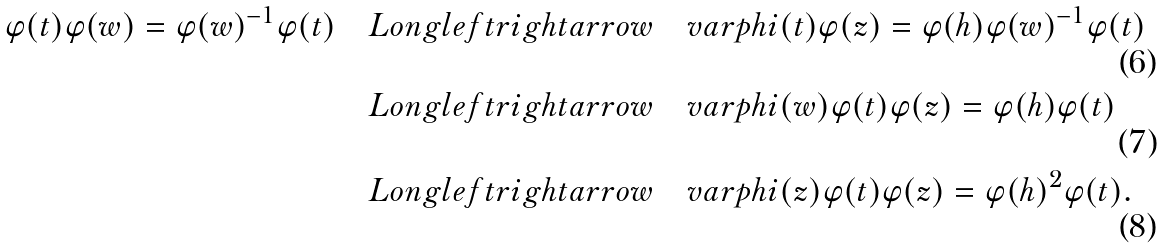<formula> <loc_0><loc_0><loc_500><loc_500>\varphi ( t ) \varphi ( w ) = \varphi ( w ) ^ { - 1 } \varphi ( t ) & \quad L o n g l e f t r i g h t a r r o w \quad v a r p h i ( t ) \varphi ( z ) = \varphi ( h ) \varphi ( w ) ^ { - 1 } \varphi ( t ) \\ & \quad L o n g l e f t r i g h t a r r o w \quad v a r p h i ( w ) \varphi ( t ) \varphi ( z ) = \varphi ( h ) \varphi ( t ) \\ & \quad L o n g l e f t r i g h t a r r o w \quad v a r p h i ( z ) \varphi ( t ) \varphi ( z ) = \varphi ( h ) ^ { 2 } \varphi ( t ) .</formula> 